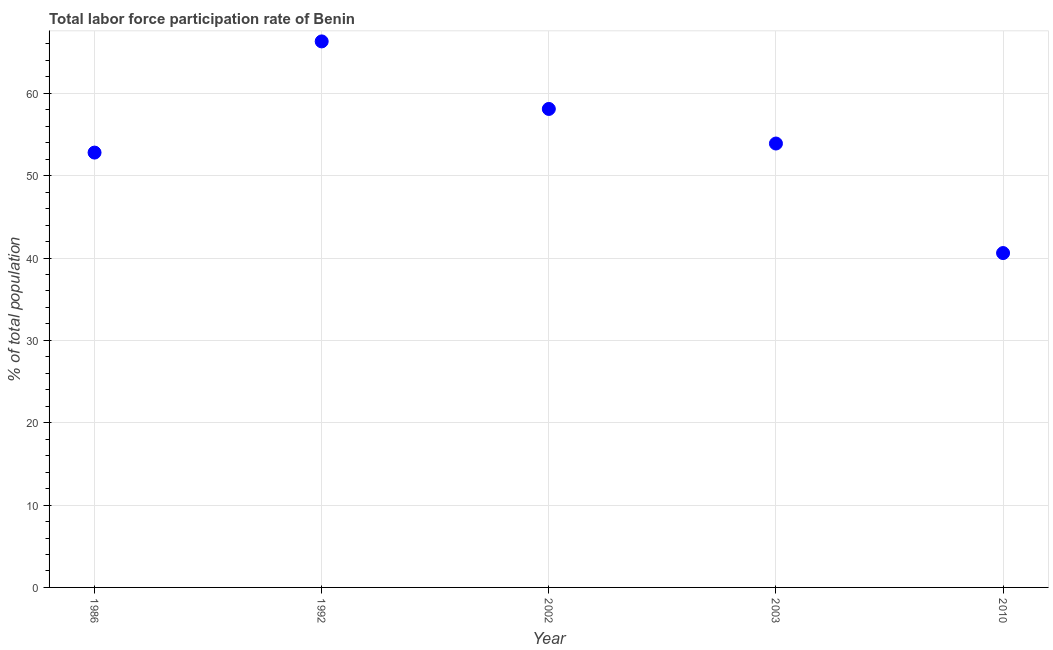What is the total labor force participation rate in 2010?
Your response must be concise. 40.6. Across all years, what is the maximum total labor force participation rate?
Your answer should be very brief. 66.3. Across all years, what is the minimum total labor force participation rate?
Give a very brief answer. 40.6. In which year was the total labor force participation rate maximum?
Keep it short and to the point. 1992. What is the sum of the total labor force participation rate?
Your answer should be very brief. 271.7. What is the difference between the total labor force participation rate in 1992 and 2002?
Your response must be concise. 8.2. What is the average total labor force participation rate per year?
Make the answer very short. 54.34. What is the median total labor force participation rate?
Give a very brief answer. 53.9. Do a majority of the years between 1992 and 2010 (inclusive) have total labor force participation rate greater than 26 %?
Your response must be concise. Yes. What is the ratio of the total labor force participation rate in 2002 to that in 2003?
Your answer should be compact. 1.08. Is the difference between the total labor force participation rate in 2002 and 2010 greater than the difference between any two years?
Your response must be concise. No. What is the difference between the highest and the second highest total labor force participation rate?
Your answer should be very brief. 8.2. What is the difference between the highest and the lowest total labor force participation rate?
Offer a terse response. 25.7. How many dotlines are there?
Your response must be concise. 1. Are the values on the major ticks of Y-axis written in scientific E-notation?
Provide a short and direct response. No. What is the title of the graph?
Provide a succinct answer. Total labor force participation rate of Benin. What is the label or title of the Y-axis?
Make the answer very short. % of total population. What is the % of total population in 1986?
Ensure brevity in your answer.  52.8. What is the % of total population in 1992?
Offer a terse response. 66.3. What is the % of total population in 2002?
Your answer should be compact. 58.1. What is the % of total population in 2003?
Make the answer very short. 53.9. What is the % of total population in 2010?
Offer a terse response. 40.6. What is the difference between the % of total population in 1986 and 1992?
Your answer should be compact. -13.5. What is the difference between the % of total population in 1986 and 2003?
Give a very brief answer. -1.1. What is the difference between the % of total population in 1992 and 2002?
Provide a succinct answer. 8.2. What is the difference between the % of total population in 1992 and 2003?
Provide a succinct answer. 12.4. What is the difference between the % of total population in 1992 and 2010?
Your answer should be compact. 25.7. What is the difference between the % of total population in 2002 and 2010?
Provide a short and direct response. 17.5. What is the ratio of the % of total population in 1986 to that in 1992?
Keep it short and to the point. 0.8. What is the ratio of the % of total population in 1986 to that in 2002?
Give a very brief answer. 0.91. What is the ratio of the % of total population in 1992 to that in 2002?
Give a very brief answer. 1.14. What is the ratio of the % of total population in 1992 to that in 2003?
Your answer should be very brief. 1.23. What is the ratio of the % of total population in 1992 to that in 2010?
Give a very brief answer. 1.63. What is the ratio of the % of total population in 2002 to that in 2003?
Make the answer very short. 1.08. What is the ratio of the % of total population in 2002 to that in 2010?
Make the answer very short. 1.43. What is the ratio of the % of total population in 2003 to that in 2010?
Make the answer very short. 1.33. 